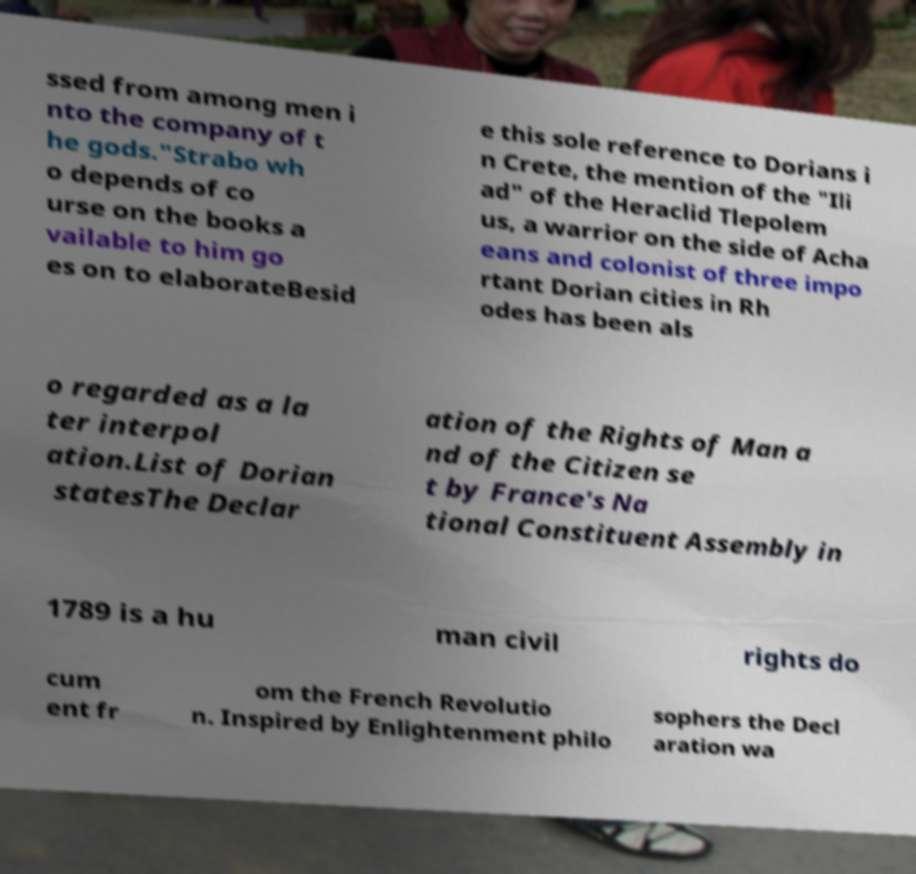There's text embedded in this image that I need extracted. Can you transcribe it verbatim? ssed from among men i nto the company of t he gods."Strabo wh o depends of co urse on the books a vailable to him go es on to elaborateBesid e this sole reference to Dorians i n Crete, the mention of the "Ili ad" of the Heraclid Tlepolem us, a warrior on the side of Acha eans and colonist of three impo rtant Dorian cities in Rh odes has been als o regarded as a la ter interpol ation.List of Dorian statesThe Declar ation of the Rights of Man a nd of the Citizen se t by France's Na tional Constituent Assembly in 1789 is a hu man civil rights do cum ent fr om the French Revolutio n. Inspired by Enlightenment philo sophers the Decl aration wa 